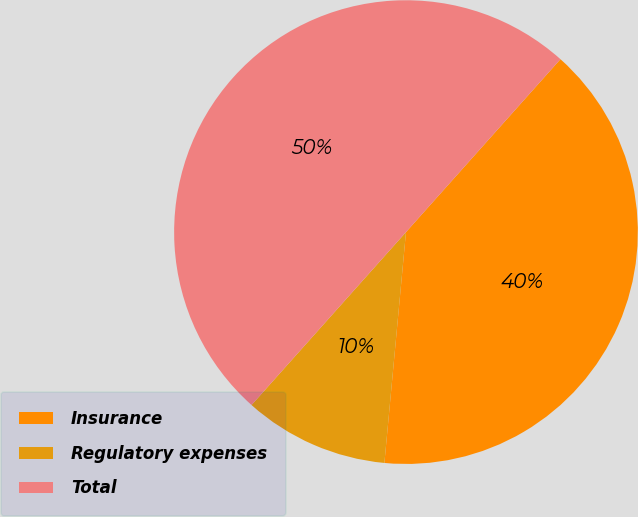Convert chart. <chart><loc_0><loc_0><loc_500><loc_500><pie_chart><fcel>Insurance<fcel>Regulatory expenses<fcel>Total<nl><fcel>39.88%<fcel>10.12%<fcel>50.0%<nl></chart> 